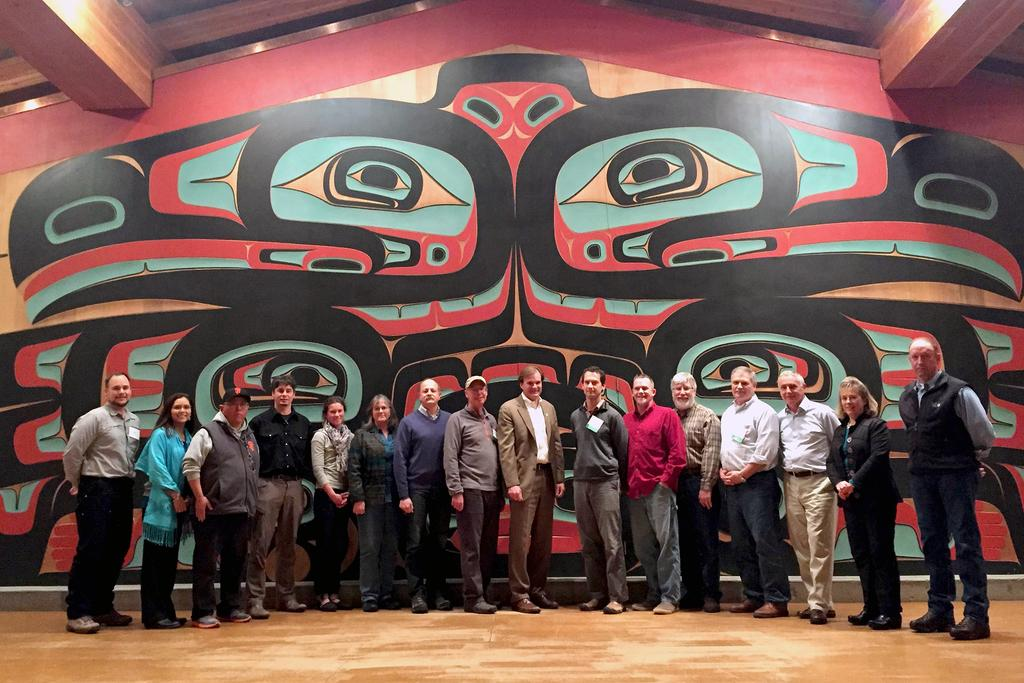What is happening in the image? There are people standing in the image. Can you describe the appearance of the people? The people are wearing different colors. What can be seen in the background of the image? There is a wall with different color painting in the background. How many tickets does the father have in the image? There is no father or tickets present in the image. What time does the clock show in the image? There are no clocks present in the image. 